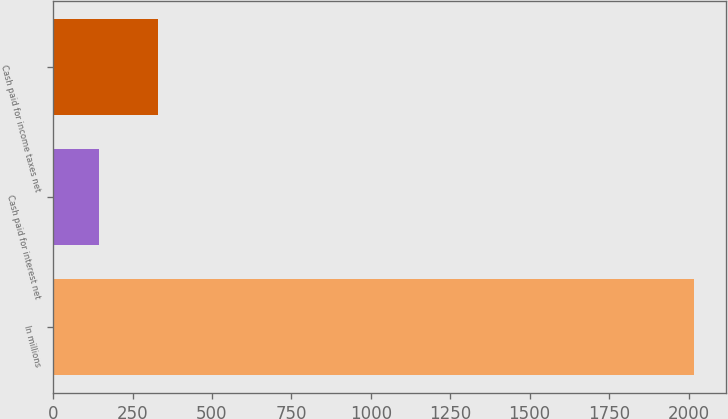<chart> <loc_0><loc_0><loc_500><loc_500><bar_chart><fcel>In millions<fcel>Cash paid for interest net<fcel>Cash paid for income taxes net<nl><fcel>2016<fcel>143.4<fcel>330.66<nl></chart> 